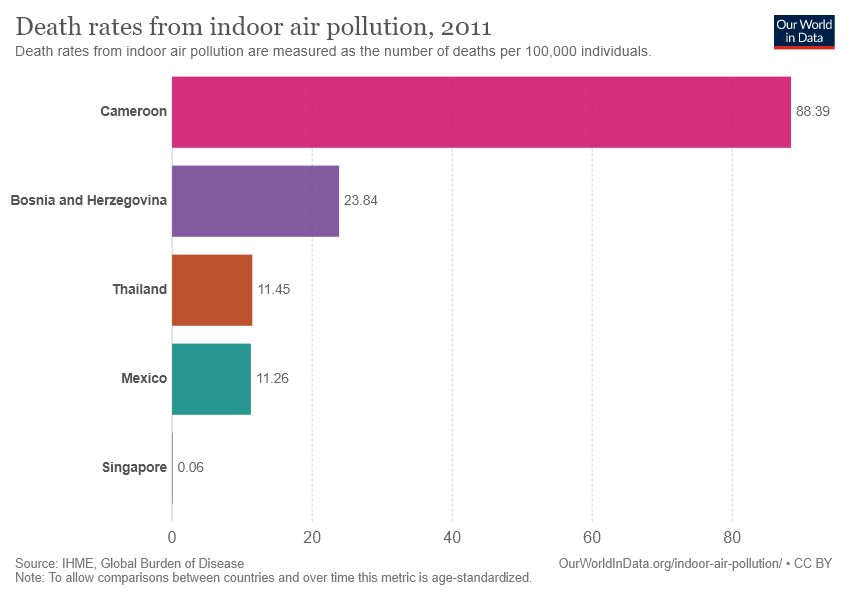List a handful of essential elements in this visual. According to available data, the current score for Cameroon is 88.39, which reflects their performance in the game so far. Cameroon is significantly larger than Mexico, with a size difference of approximately 7.85 times. 